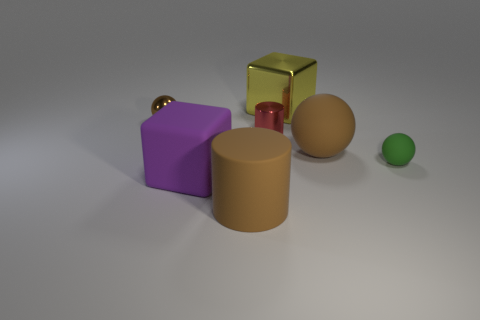What material is the small sphere on the right side of the big cube that is behind the tiny rubber sphere?
Keep it short and to the point. Rubber. What number of rubber objects are tiny gray blocks or big purple blocks?
Provide a succinct answer. 1. What is the color of the other big object that is the same shape as the green object?
Provide a short and direct response. Brown. What number of large spheres are the same color as the tiny cylinder?
Offer a terse response. 0. There is a tiny shiny thing behind the red metallic thing; are there any purple rubber objects that are behind it?
Offer a very short reply. No. What number of objects are both in front of the small brown sphere and right of the large cylinder?
Make the answer very short. 3. How many small cylinders are made of the same material as the large cylinder?
Offer a terse response. 0. What size is the sphere in front of the matte ball left of the green thing?
Give a very brief answer. Small. Are there any big matte things that have the same shape as the tiny brown thing?
Ensure brevity in your answer.  Yes. There is a brown sphere in front of the small red metallic cylinder; is it the same size as the cylinder that is right of the big brown cylinder?
Keep it short and to the point. No. 